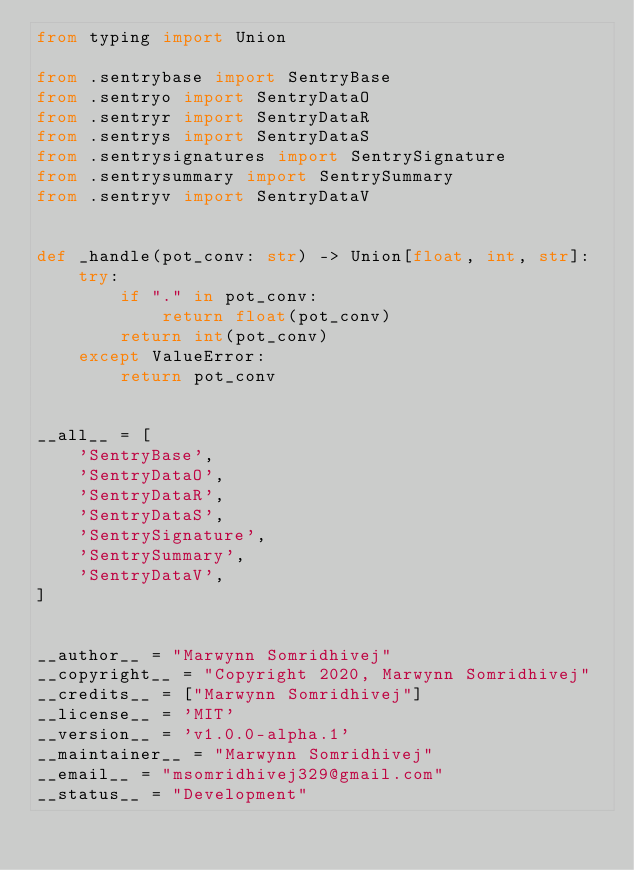Convert code to text. <code><loc_0><loc_0><loc_500><loc_500><_Python_>from typing import Union

from .sentrybase import SentryBase
from .sentryo import SentryDataO
from .sentryr import SentryDataR
from .sentrys import SentryDataS
from .sentrysignatures import SentrySignature
from .sentrysummary import SentrySummary
from .sentryv import SentryDataV


def _handle(pot_conv: str) -> Union[float, int, str]:
    try:
        if "." in pot_conv:
            return float(pot_conv)
        return int(pot_conv)
    except ValueError:
        return pot_conv


__all__ = [
    'SentryBase',
    'SentryDataO',
    'SentryDataR',
    'SentryDataS',
    'SentrySignature',
    'SentrySummary',
    'SentryDataV',
]


__author__ = "Marwynn Somridhivej"
__copyright__ = "Copyright 2020, Marwynn Somridhivej"
__credits__ = ["Marwynn Somridhivej"]
__license__ = 'MIT'
__version__ = 'v1.0.0-alpha.1'
__maintainer__ = "Marwynn Somridhivej"
__email__ = "msomridhivej329@gmail.com"
__status__ = "Development"
</code> 